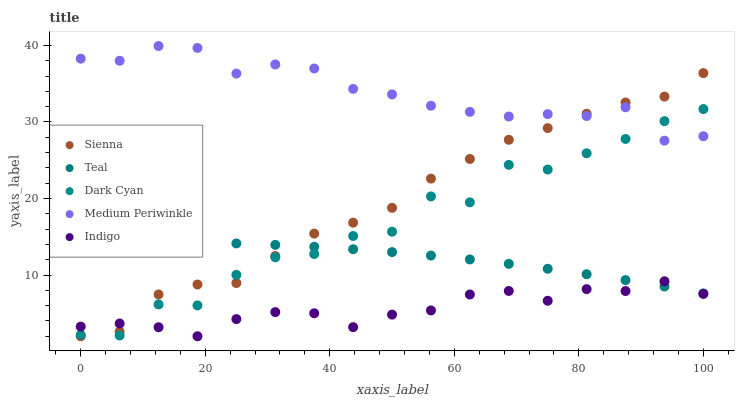Does Indigo have the minimum area under the curve?
Answer yes or no. Yes. Does Medium Periwinkle have the maximum area under the curve?
Answer yes or no. Yes. Does Dark Cyan have the minimum area under the curve?
Answer yes or no. No. Does Dark Cyan have the maximum area under the curve?
Answer yes or no. No. Is Teal the smoothest?
Answer yes or no. Yes. Is Dark Cyan the roughest?
Answer yes or no. Yes. Is Medium Periwinkle the smoothest?
Answer yes or no. No. Is Medium Periwinkle the roughest?
Answer yes or no. No. Does Sienna have the lowest value?
Answer yes or no. Yes. Does Dark Cyan have the lowest value?
Answer yes or no. No. Does Medium Periwinkle have the highest value?
Answer yes or no. Yes. Does Dark Cyan have the highest value?
Answer yes or no. No. Is Indigo less than Medium Periwinkle?
Answer yes or no. Yes. Is Medium Periwinkle greater than Indigo?
Answer yes or no. Yes. Does Dark Cyan intersect Teal?
Answer yes or no. Yes. Is Dark Cyan less than Teal?
Answer yes or no. No. Is Dark Cyan greater than Teal?
Answer yes or no. No. Does Indigo intersect Medium Periwinkle?
Answer yes or no. No. 